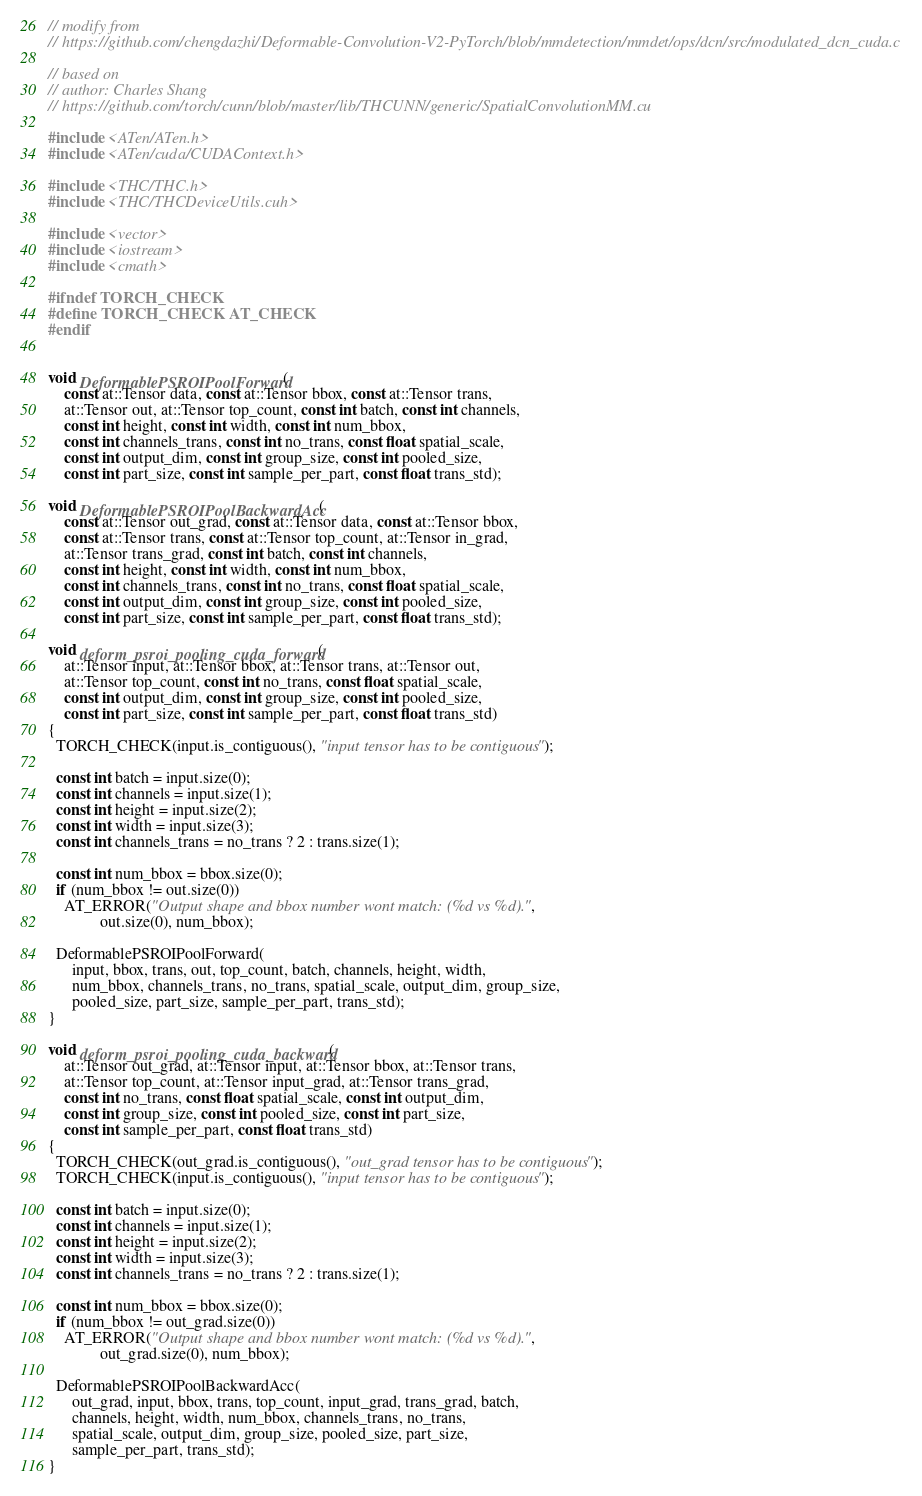Convert code to text. <code><loc_0><loc_0><loc_500><loc_500><_Cuda_>// modify from
// https://github.com/chengdazhi/Deformable-Convolution-V2-PyTorch/blob/mmdetection/mmdet/ops/dcn/src/modulated_dcn_cuda.c

// based on
// author: Charles Shang
// https://github.com/torch/cunn/blob/master/lib/THCUNN/generic/SpatialConvolutionMM.cu

#include <ATen/ATen.h>
#include <ATen/cuda/CUDAContext.h>

#include <THC/THC.h>
#include <THC/THCDeviceUtils.cuh>

#include <vector>
#include <iostream>
#include <cmath>

#ifndef TORCH_CHECK
#define TORCH_CHECK AT_CHECK
#endif


void DeformablePSROIPoolForward(
    const at::Tensor data, const at::Tensor bbox, const at::Tensor trans,
    at::Tensor out, at::Tensor top_count, const int batch, const int channels,
    const int height, const int width, const int num_bbox,
    const int channels_trans, const int no_trans, const float spatial_scale,
    const int output_dim, const int group_size, const int pooled_size,
    const int part_size, const int sample_per_part, const float trans_std);

void DeformablePSROIPoolBackwardAcc(
    const at::Tensor out_grad, const at::Tensor data, const at::Tensor bbox,
    const at::Tensor trans, const at::Tensor top_count, at::Tensor in_grad,
    at::Tensor trans_grad, const int batch, const int channels,
    const int height, const int width, const int num_bbox,
    const int channels_trans, const int no_trans, const float spatial_scale,
    const int output_dim, const int group_size, const int pooled_size,
    const int part_size, const int sample_per_part, const float trans_std);

void deform_psroi_pooling_cuda_forward(
    at::Tensor input, at::Tensor bbox, at::Tensor trans, at::Tensor out,
    at::Tensor top_count, const int no_trans, const float spatial_scale,
    const int output_dim, const int group_size, const int pooled_size,
    const int part_size, const int sample_per_part, const float trans_std) 
{
  TORCH_CHECK(input.is_contiguous(), "input tensor has to be contiguous");

  const int batch = input.size(0);
  const int channels = input.size(1);
  const int height = input.size(2);
  const int width = input.size(3);
  const int channels_trans = no_trans ? 2 : trans.size(1);

  const int num_bbox = bbox.size(0);
  if (num_bbox != out.size(0))
    AT_ERROR("Output shape and bbox number wont match: (%d vs %d).",
             out.size(0), num_bbox);

  DeformablePSROIPoolForward(
      input, bbox, trans, out, top_count, batch, channels, height, width,
      num_bbox, channels_trans, no_trans, spatial_scale, output_dim, group_size,
      pooled_size, part_size, sample_per_part, trans_std);
}

void deform_psroi_pooling_cuda_backward(
    at::Tensor out_grad, at::Tensor input, at::Tensor bbox, at::Tensor trans,
    at::Tensor top_count, at::Tensor input_grad, at::Tensor trans_grad,
    const int no_trans, const float spatial_scale, const int output_dim,
    const int group_size, const int pooled_size, const int part_size,
    const int sample_per_part, const float trans_std) 
{
  TORCH_CHECK(out_grad.is_contiguous(), "out_grad tensor has to be contiguous");
  TORCH_CHECK(input.is_contiguous(), "input tensor has to be contiguous");

  const int batch = input.size(0);
  const int channels = input.size(1);
  const int height = input.size(2);
  const int width = input.size(3);
  const int channels_trans = no_trans ? 2 : trans.size(1);

  const int num_bbox = bbox.size(0);
  if (num_bbox != out_grad.size(0))
    AT_ERROR("Output shape and bbox number wont match: (%d vs %d).",
             out_grad.size(0), num_bbox);

  DeformablePSROIPoolBackwardAcc(
      out_grad, input, bbox, trans, top_count, input_grad, trans_grad, batch,
      channels, height, width, num_bbox, channels_trans, no_trans,
      spatial_scale, output_dim, group_size, pooled_size, part_size,
      sample_per_part, trans_std);
}
</code> 